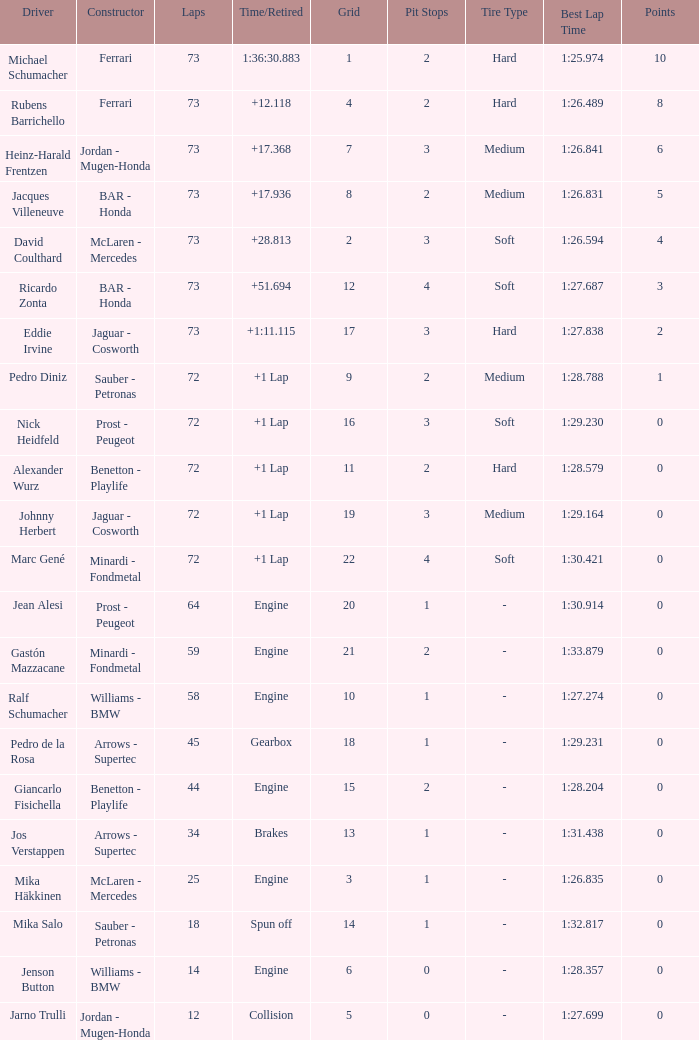How many laps did Giancarlo Fisichella do with a grid larger than 15? 0.0. 